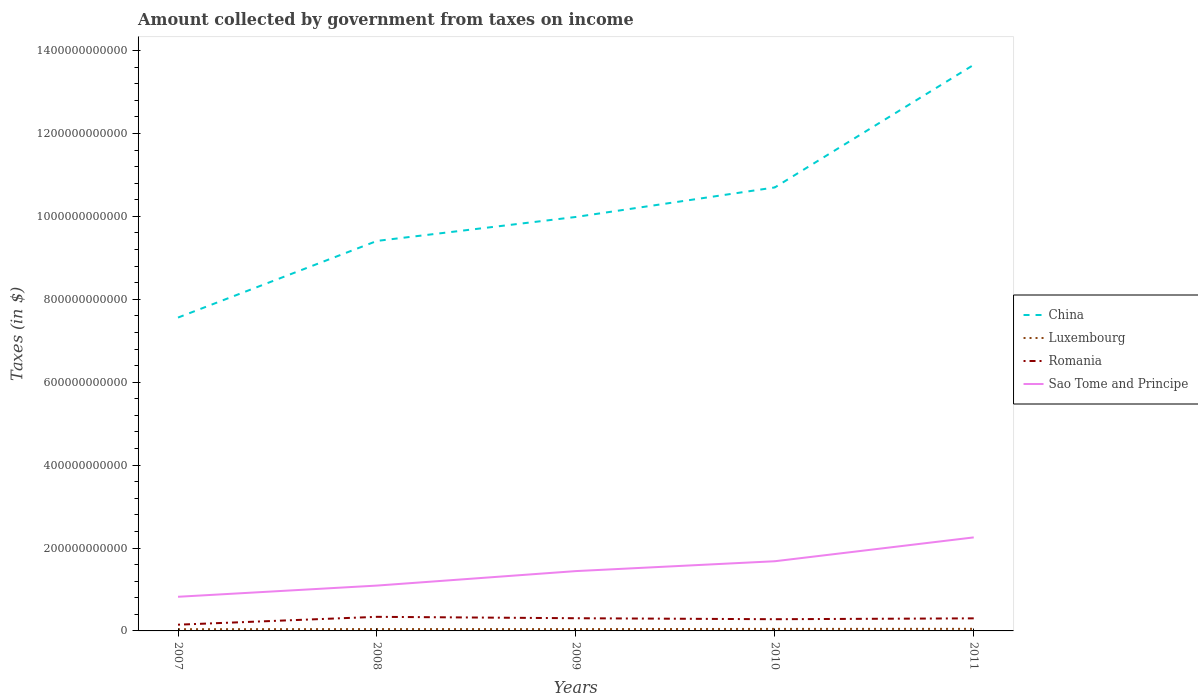How many different coloured lines are there?
Ensure brevity in your answer.  4. Across all years, what is the maximum amount collected by government from taxes on income in Romania?
Keep it short and to the point. 1.50e+1. In which year was the amount collected by government from taxes on income in China maximum?
Ensure brevity in your answer.  2007. What is the total amount collected by government from taxes on income in China in the graph?
Offer a very short reply. -2.43e+11. What is the difference between the highest and the second highest amount collected by government from taxes on income in Romania?
Provide a succinct answer. 1.90e+1. Is the amount collected by government from taxes on income in Luxembourg strictly greater than the amount collected by government from taxes on income in China over the years?
Provide a succinct answer. Yes. How many years are there in the graph?
Offer a terse response. 5. What is the difference between two consecutive major ticks on the Y-axis?
Your answer should be compact. 2.00e+11. Are the values on the major ticks of Y-axis written in scientific E-notation?
Offer a very short reply. No. Where does the legend appear in the graph?
Ensure brevity in your answer.  Center right. What is the title of the graph?
Provide a succinct answer. Amount collected by government from taxes on income. What is the label or title of the Y-axis?
Ensure brevity in your answer.  Taxes (in $). What is the Taxes (in $) of China in 2007?
Offer a terse response. 7.56e+11. What is the Taxes (in $) in Luxembourg in 2007?
Ensure brevity in your answer.  4.12e+09. What is the Taxes (in $) of Romania in 2007?
Ensure brevity in your answer.  1.50e+1. What is the Taxes (in $) in Sao Tome and Principe in 2007?
Give a very brief answer. 8.24e+1. What is the Taxes (in $) of China in 2008?
Keep it short and to the point. 9.41e+11. What is the Taxes (in $) of Luxembourg in 2008?
Your answer should be very brief. 4.46e+09. What is the Taxes (in $) of Romania in 2008?
Your answer should be very brief. 3.40e+1. What is the Taxes (in $) in Sao Tome and Principe in 2008?
Keep it short and to the point. 1.09e+11. What is the Taxes (in $) in China in 2009?
Your response must be concise. 9.99e+11. What is the Taxes (in $) of Luxembourg in 2009?
Offer a terse response. 4.41e+09. What is the Taxes (in $) in Romania in 2009?
Keep it short and to the point. 3.06e+1. What is the Taxes (in $) in Sao Tome and Principe in 2009?
Provide a succinct answer. 1.44e+11. What is the Taxes (in $) in China in 2010?
Your answer should be very brief. 1.07e+12. What is the Taxes (in $) of Luxembourg in 2010?
Your answer should be compact. 4.86e+09. What is the Taxes (in $) of Romania in 2010?
Your response must be concise. 2.82e+1. What is the Taxes (in $) in Sao Tome and Principe in 2010?
Your answer should be compact. 1.68e+11. What is the Taxes (in $) in China in 2011?
Make the answer very short. 1.37e+12. What is the Taxes (in $) of Luxembourg in 2011?
Offer a terse response. 5.00e+09. What is the Taxes (in $) in Romania in 2011?
Offer a very short reply. 3.03e+1. What is the Taxes (in $) in Sao Tome and Principe in 2011?
Give a very brief answer. 2.26e+11. Across all years, what is the maximum Taxes (in $) of China?
Your response must be concise. 1.37e+12. Across all years, what is the maximum Taxes (in $) of Luxembourg?
Offer a terse response. 5.00e+09. Across all years, what is the maximum Taxes (in $) of Romania?
Keep it short and to the point. 3.40e+1. Across all years, what is the maximum Taxes (in $) in Sao Tome and Principe?
Your answer should be compact. 2.26e+11. Across all years, what is the minimum Taxes (in $) in China?
Provide a succinct answer. 7.56e+11. Across all years, what is the minimum Taxes (in $) in Luxembourg?
Your answer should be very brief. 4.12e+09. Across all years, what is the minimum Taxes (in $) in Romania?
Your answer should be compact. 1.50e+1. Across all years, what is the minimum Taxes (in $) in Sao Tome and Principe?
Offer a very short reply. 8.24e+1. What is the total Taxes (in $) of China in the graph?
Keep it short and to the point. 5.13e+12. What is the total Taxes (in $) of Luxembourg in the graph?
Offer a terse response. 2.29e+1. What is the total Taxes (in $) of Romania in the graph?
Your answer should be compact. 1.38e+11. What is the total Taxes (in $) in Sao Tome and Principe in the graph?
Your answer should be very brief. 7.30e+11. What is the difference between the Taxes (in $) of China in 2007 and that in 2008?
Keep it short and to the point. -1.85e+11. What is the difference between the Taxes (in $) in Luxembourg in 2007 and that in 2008?
Give a very brief answer. -3.46e+08. What is the difference between the Taxes (in $) of Romania in 2007 and that in 2008?
Provide a succinct answer. -1.90e+1. What is the difference between the Taxes (in $) of Sao Tome and Principe in 2007 and that in 2008?
Offer a very short reply. -2.70e+1. What is the difference between the Taxes (in $) of China in 2007 and that in 2009?
Make the answer very short. -2.43e+11. What is the difference between the Taxes (in $) in Luxembourg in 2007 and that in 2009?
Keep it short and to the point. -2.90e+08. What is the difference between the Taxes (in $) in Romania in 2007 and that in 2009?
Ensure brevity in your answer.  -1.56e+1. What is the difference between the Taxes (in $) of Sao Tome and Principe in 2007 and that in 2009?
Provide a succinct answer. -6.19e+1. What is the difference between the Taxes (in $) in China in 2007 and that in 2010?
Your answer should be compact. -3.14e+11. What is the difference between the Taxes (in $) in Luxembourg in 2007 and that in 2010?
Your response must be concise. -7.47e+08. What is the difference between the Taxes (in $) in Romania in 2007 and that in 2010?
Give a very brief answer. -1.32e+1. What is the difference between the Taxes (in $) of Sao Tome and Principe in 2007 and that in 2010?
Ensure brevity in your answer.  -8.57e+1. What is the difference between the Taxes (in $) in China in 2007 and that in 2011?
Give a very brief answer. -6.10e+11. What is the difference between the Taxes (in $) of Luxembourg in 2007 and that in 2011?
Your response must be concise. -8.86e+08. What is the difference between the Taxes (in $) in Romania in 2007 and that in 2011?
Offer a terse response. -1.53e+1. What is the difference between the Taxes (in $) in Sao Tome and Principe in 2007 and that in 2011?
Your answer should be compact. -1.43e+11. What is the difference between the Taxes (in $) in China in 2008 and that in 2009?
Ensure brevity in your answer.  -5.78e+1. What is the difference between the Taxes (in $) in Luxembourg in 2008 and that in 2009?
Keep it short and to the point. 5.69e+07. What is the difference between the Taxes (in $) in Romania in 2008 and that in 2009?
Keep it short and to the point. 3.39e+09. What is the difference between the Taxes (in $) of Sao Tome and Principe in 2008 and that in 2009?
Your answer should be compact. -3.49e+1. What is the difference between the Taxes (in $) in China in 2008 and that in 2010?
Offer a very short reply. -1.29e+11. What is the difference between the Taxes (in $) in Luxembourg in 2008 and that in 2010?
Ensure brevity in your answer.  -4.00e+08. What is the difference between the Taxes (in $) in Romania in 2008 and that in 2010?
Offer a terse response. 5.76e+09. What is the difference between the Taxes (in $) in Sao Tome and Principe in 2008 and that in 2010?
Give a very brief answer. -5.87e+1. What is the difference between the Taxes (in $) of China in 2008 and that in 2011?
Provide a short and direct response. -4.25e+11. What is the difference between the Taxes (in $) in Luxembourg in 2008 and that in 2011?
Ensure brevity in your answer.  -5.40e+08. What is the difference between the Taxes (in $) of Romania in 2008 and that in 2011?
Offer a very short reply. 3.68e+09. What is the difference between the Taxes (in $) of Sao Tome and Principe in 2008 and that in 2011?
Offer a terse response. -1.16e+11. What is the difference between the Taxes (in $) in China in 2009 and that in 2010?
Provide a succinct answer. -7.12e+1. What is the difference between the Taxes (in $) of Luxembourg in 2009 and that in 2010?
Your answer should be compact. -4.57e+08. What is the difference between the Taxes (in $) in Romania in 2009 and that in 2010?
Offer a terse response. 2.37e+09. What is the difference between the Taxes (in $) of Sao Tome and Principe in 2009 and that in 2010?
Your answer should be compact. -2.38e+1. What is the difference between the Taxes (in $) in China in 2009 and that in 2011?
Give a very brief answer. -3.67e+11. What is the difference between the Taxes (in $) of Luxembourg in 2009 and that in 2011?
Provide a succinct answer. -5.97e+08. What is the difference between the Taxes (in $) of Romania in 2009 and that in 2011?
Your answer should be compact. 2.83e+08. What is the difference between the Taxes (in $) of Sao Tome and Principe in 2009 and that in 2011?
Keep it short and to the point. -8.13e+1. What is the difference between the Taxes (in $) in China in 2010 and that in 2011?
Keep it short and to the point. -2.96e+11. What is the difference between the Taxes (in $) of Luxembourg in 2010 and that in 2011?
Ensure brevity in your answer.  -1.40e+08. What is the difference between the Taxes (in $) of Romania in 2010 and that in 2011?
Ensure brevity in your answer.  -2.09e+09. What is the difference between the Taxes (in $) in Sao Tome and Principe in 2010 and that in 2011?
Your response must be concise. -5.75e+1. What is the difference between the Taxes (in $) of China in 2007 and the Taxes (in $) of Luxembourg in 2008?
Give a very brief answer. 7.51e+11. What is the difference between the Taxes (in $) in China in 2007 and the Taxes (in $) in Romania in 2008?
Keep it short and to the point. 7.22e+11. What is the difference between the Taxes (in $) of China in 2007 and the Taxes (in $) of Sao Tome and Principe in 2008?
Give a very brief answer. 6.46e+11. What is the difference between the Taxes (in $) in Luxembourg in 2007 and the Taxes (in $) in Romania in 2008?
Your answer should be very brief. -2.99e+1. What is the difference between the Taxes (in $) of Luxembourg in 2007 and the Taxes (in $) of Sao Tome and Principe in 2008?
Offer a very short reply. -1.05e+11. What is the difference between the Taxes (in $) of Romania in 2007 and the Taxes (in $) of Sao Tome and Principe in 2008?
Ensure brevity in your answer.  -9.44e+1. What is the difference between the Taxes (in $) of China in 2007 and the Taxes (in $) of Luxembourg in 2009?
Ensure brevity in your answer.  7.51e+11. What is the difference between the Taxes (in $) in China in 2007 and the Taxes (in $) in Romania in 2009?
Your answer should be compact. 7.25e+11. What is the difference between the Taxes (in $) in China in 2007 and the Taxes (in $) in Sao Tome and Principe in 2009?
Offer a terse response. 6.12e+11. What is the difference between the Taxes (in $) of Luxembourg in 2007 and the Taxes (in $) of Romania in 2009?
Provide a short and direct response. -2.65e+1. What is the difference between the Taxes (in $) in Luxembourg in 2007 and the Taxes (in $) in Sao Tome and Principe in 2009?
Your response must be concise. -1.40e+11. What is the difference between the Taxes (in $) of Romania in 2007 and the Taxes (in $) of Sao Tome and Principe in 2009?
Offer a terse response. -1.29e+11. What is the difference between the Taxes (in $) in China in 2007 and the Taxes (in $) in Luxembourg in 2010?
Give a very brief answer. 7.51e+11. What is the difference between the Taxes (in $) of China in 2007 and the Taxes (in $) of Romania in 2010?
Give a very brief answer. 7.28e+11. What is the difference between the Taxes (in $) in China in 2007 and the Taxes (in $) in Sao Tome and Principe in 2010?
Provide a succinct answer. 5.88e+11. What is the difference between the Taxes (in $) in Luxembourg in 2007 and the Taxes (in $) in Romania in 2010?
Your answer should be very brief. -2.41e+1. What is the difference between the Taxes (in $) in Luxembourg in 2007 and the Taxes (in $) in Sao Tome and Principe in 2010?
Your response must be concise. -1.64e+11. What is the difference between the Taxes (in $) of Romania in 2007 and the Taxes (in $) of Sao Tome and Principe in 2010?
Ensure brevity in your answer.  -1.53e+11. What is the difference between the Taxes (in $) of China in 2007 and the Taxes (in $) of Luxembourg in 2011?
Your response must be concise. 7.51e+11. What is the difference between the Taxes (in $) in China in 2007 and the Taxes (in $) in Romania in 2011?
Keep it short and to the point. 7.26e+11. What is the difference between the Taxes (in $) of China in 2007 and the Taxes (in $) of Sao Tome and Principe in 2011?
Keep it short and to the point. 5.30e+11. What is the difference between the Taxes (in $) of Luxembourg in 2007 and the Taxes (in $) of Romania in 2011?
Offer a terse response. -2.62e+1. What is the difference between the Taxes (in $) of Luxembourg in 2007 and the Taxes (in $) of Sao Tome and Principe in 2011?
Provide a short and direct response. -2.21e+11. What is the difference between the Taxes (in $) of Romania in 2007 and the Taxes (in $) of Sao Tome and Principe in 2011?
Keep it short and to the point. -2.11e+11. What is the difference between the Taxes (in $) in China in 2008 and the Taxes (in $) in Luxembourg in 2009?
Keep it short and to the point. 9.36e+11. What is the difference between the Taxes (in $) in China in 2008 and the Taxes (in $) in Romania in 2009?
Make the answer very short. 9.10e+11. What is the difference between the Taxes (in $) in China in 2008 and the Taxes (in $) in Sao Tome and Principe in 2009?
Offer a very short reply. 7.96e+11. What is the difference between the Taxes (in $) of Luxembourg in 2008 and the Taxes (in $) of Romania in 2009?
Offer a terse response. -2.61e+1. What is the difference between the Taxes (in $) of Luxembourg in 2008 and the Taxes (in $) of Sao Tome and Principe in 2009?
Your response must be concise. -1.40e+11. What is the difference between the Taxes (in $) in Romania in 2008 and the Taxes (in $) in Sao Tome and Principe in 2009?
Offer a very short reply. -1.10e+11. What is the difference between the Taxes (in $) in China in 2008 and the Taxes (in $) in Luxembourg in 2010?
Provide a succinct answer. 9.36e+11. What is the difference between the Taxes (in $) of China in 2008 and the Taxes (in $) of Romania in 2010?
Provide a succinct answer. 9.13e+11. What is the difference between the Taxes (in $) in China in 2008 and the Taxes (in $) in Sao Tome and Principe in 2010?
Offer a terse response. 7.73e+11. What is the difference between the Taxes (in $) of Luxembourg in 2008 and the Taxes (in $) of Romania in 2010?
Your answer should be very brief. -2.38e+1. What is the difference between the Taxes (in $) in Luxembourg in 2008 and the Taxes (in $) in Sao Tome and Principe in 2010?
Make the answer very short. -1.64e+11. What is the difference between the Taxes (in $) of Romania in 2008 and the Taxes (in $) of Sao Tome and Principe in 2010?
Your response must be concise. -1.34e+11. What is the difference between the Taxes (in $) in China in 2008 and the Taxes (in $) in Luxembourg in 2011?
Make the answer very short. 9.36e+11. What is the difference between the Taxes (in $) in China in 2008 and the Taxes (in $) in Romania in 2011?
Provide a short and direct response. 9.10e+11. What is the difference between the Taxes (in $) in China in 2008 and the Taxes (in $) in Sao Tome and Principe in 2011?
Keep it short and to the point. 7.15e+11. What is the difference between the Taxes (in $) in Luxembourg in 2008 and the Taxes (in $) in Romania in 2011?
Give a very brief answer. -2.59e+1. What is the difference between the Taxes (in $) in Luxembourg in 2008 and the Taxes (in $) in Sao Tome and Principe in 2011?
Make the answer very short. -2.21e+11. What is the difference between the Taxes (in $) in Romania in 2008 and the Taxes (in $) in Sao Tome and Principe in 2011?
Your answer should be compact. -1.92e+11. What is the difference between the Taxes (in $) of China in 2009 and the Taxes (in $) of Luxembourg in 2010?
Ensure brevity in your answer.  9.94e+11. What is the difference between the Taxes (in $) of China in 2009 and the Taxes (in $) of Romania in 2010?
Your answer should be very brief. 9.70e+11. What is the difference between the Taxes (in $) of China in 2009 and the Taxes (in $) of Sao Tome and Principe in 2010?
Give a very brief answer. 8.30e+11. What is the difference between the Taxes (in $) in Luxembourg in 2009 and the Taxes (in $) in Romania in 2010?
Keep it short and to the point. -2.38e+1. What is the difference between the Taxes (in $) of Luxembourg in 2009 and the Taxes (in $) of Sao Tome and Principe in 2010?
Your response must be concise. -1.64e+11. What is the difference between the Taxes (in $) in Romania in 2009 and the Taxes (in $) in Sao Tome and Principe in 2010?
Keep it short and to the point. -1.37e+11. What is the difference between the Taxes (in $) in China in 2009 and the Taxes (in $) in Luxembourg in 2011?
Provide a succinct answer. 9.94e+11. What is the difference between the Taxes (in $) in China in 2009 and the Taxes (in $) in Romania in 2011?
Your answer should be very brief. 9.68e+11. What is the difference between the Taxes (in $) of China in 2009 and the Taxes (in $) of Sao Tome and Principe in 2011?
Ensure brevity in your answer.  7.73e+11. What is the difference between the Taxes (in $) of Luxembourg in 2009 and the Taxes (in $) of Romania in 2011?
Give a very brief answer. -2.59e+1. What is the difference between the Taxes (in $) of Luxembourg in 2009 and the Taxes (in $) of Sao Tome and Principe in 2011?
Provide a short and direct response. -2.21e+11. What is the difference between the Taxes (in $) in Romania in 2009 and the Taxes (in $) in Sao Tome and Principe in 2011?
Provide a short and direct response. -1.95e+11. What is the difference between the Taxes (in $) of China in 2010 and the Taxes (in $) of Luxembourg in 2011?
Your answer should be compact. 1.06e+12. What is the difference between the Taxes (in $) in China in 2010 and the Taxes (in $) in Romania in 2011?
Provide a succinct answer. 1.04e+12. What is the difference between the Taxes (in $) in China in 2010 and the Taxes (in $) in Sao Tome and Principe in 2011?
Make the answer very short. 8.44e+11. What is the difference between the Taxes (in $) of Luxembourg in 2010 and the Taxes (in $) of Romania in 2011?
Give a very brief answer. -2.55e+1. What is the difference between the Taxes (in $) of Luxembourg in 2010 and the Taxes (in $) of Sao Tome and Principe in 2011?
Give a very brief answer. -2.21e+11. What is the difference between the Taxes (in $) of Romania in 2010 and the Taxes (in $) of Sao Tome and Principe in 2011?
Offer a very short reply. -1.97e+11. What is the average Taxes (in $) of China per year?
Offer a very short reply. 1.03e+12. What is the average Taxes (in $) in Luxembourg per year?
Your answer should be compact. 4.57e+09. What is the average Taxes (in $) in Romania per year?
Offer a very short reply. 2.76e+1. What is the average Taxes (in $) of Sao Tome and Principe per year?
Offer a terse response. 1.46e+11. In the year 2007, what is the difference between the Taxes (in $) of China and Taxes (in $) of Luxembourg?
Make the answer very short. 7.52e+11. In the year 2007, what is the difference between the Taxes (in $) of China and Taxes (in $) of Romania?
Your answer should be very brief. 7.41e+11. In the year 2007, what is the difference between the Taxes (in $) in China and Taxes (in $) in Sao Tome and Principe?
Offer a terse response. 6.74e+11. In the year 2007, what is the difference between the Taxes (in $) in Luxembourg and Taxes (in $) in Romania?
Keep it short and to the point. -1.09e+1. In the year 2007, what is the difference between the Taxes (in $) of Luxembourg and Taxes (in $) of Sao Tome and Principe?
Offer a very short reply. -7.83e+1. In the year 2007, what is the difference between the Taxes (in $) of Romania and Taxes (in $) of Sao Tome and Principe?
Your answer should be compact. -6.74e+1. In the year 2008, what is the difference between the Taxes (in $) of China and Taxes (in $) of Luxembourg?
Offer a very short reply. 9.36e+11. In the year 2008, what is the difference between the Taxes (in $) of China and Taxes (in $) of Romania?
Make the answer very short. 9.07e+11. In the year 2008, what is the difference between the Taxes (in $) in China and Taxes (in $) in Sao Tome and Principe?
Make the answer very short. 8.31e+11. In the year 2008, what is the difference between the Taxes (in $) of Luxembourg and Taxes (in $) of Romania?
Provide a succinct answer. -2.95e+1. In the year 2008, what is the difference between the Taxes (in $) in Luxembourg and Taxes (in $) in Sao Tome and Principe?
Offer a very short reply. -1.05e+11. In the year 2008, what is the difference between the Taxes (in $) of Romania and Taxes (in $) of Sao Tome and Principe?
Your answer should be very brief. -7.54e+1. In the year 2009, what is the difference between the Taxes (in $) in China and Taxes (in $) in Luxembourg?
Provide a short and direct response. 9.94e+11. In the year 2009, what is the difference between the Taxes (in $) of China and Taxes (in $) of Romania?
Provide a succinct answer. 9.68e+11. In the year 2009, what is the difference between the Taxes (in $) of China and Taxes (in $) of Sao Tome and Principe?
Your response must be concise. 8.54e+11. In the year 2009, what is the difference between the Taxes (in $) of Luxembourg and Taxes (in $) of Romania?
Make the answer very short. -2.62e+1. In the year 2009, what is the difference between the Taxes (in $) in Luxembourg and Taxes (in $) in Sao Tome and Principe?
Give a very brief answer. -1.40e+11. In the year 2009, what is the difference between the Taxes (in $) in Romania and Taxes (in $) in Sao Tome and Principe?
Make the answer very short. -1.14e+11. In the year 2010, what is the difference between the Taxes (in $) in China and Taxes (in $) in Luxembourg?
Offer a terse response. 1.06e+12. In the year 2010, what is the difference between the Taxes (in $) in China and Taxes (in $) in Romania?
Offer a terse response. 1.04e+12. In the year 2010, what is the difference between the Taxes (in $) in China and Taxes (in $) in Sao Tome and Principe?
Keep it short and to the point. 9.02e+11. In the year 2010, what is the difference between the Taxes (in $) in Luxembourg and Taxes (in $) in Romania?
Ensure brevity in your answer.  -2.34e+1. In the year 2010, what is the difference between the Taxes (in $) of Luxembourg and Taxes (in $) of Sao Tome and Principe?
Your response must be concise. -1.63e+11. In the year 2010, what is the difference between the Taxes (in $) of Romania and Taxes (in $) of Sao Tome and Principe?
Your answer should be very brief. -1.40e+11. In the year 2011, what is the difference between the Taxes (in $) of China and Taxes (in $) of Luxembourg?
Your response must be concise. 1.36e+12. In the year 2011, what is the difference between the Taxes (in $) in China and Taxes (in $) in Romania?
Your answer should be very brief. 1.34e+12. In the year 2011, what is the difference between the Taxes (in $) in China and Taxes (in $) in Sao Tome and Principe?
Ensure brevity in your answer.  1.14e+12. In the year 2011, what is the difference between the Taxes (in $) in Luxembourg and Taxes (in $) in Romania?
Offer a very short reply. -2.53e+1. In the year 2011, what is the difference between the Taxes (in $) of Luxembourg and Taxes (in $) of Sao Tome and Principe?
Your answer should be compact. -2.21e+11. In the year 2011, what is the difference between the Taxes (in $) of Romania and Taxes (in $) of Sao Tome and Principe?
Provide a succinct answer. -1.95e+11. What is the ratio of the Taxes (in $) of China in 2007 to that in 2008?
Ensure brevity in your answer.  0.8. What is the ratio of the Taxes (in $) of Luxembourg in 2007 to that in 2008?
Your response must be concise. 0.92. What is the ratio of the Taxes (in $) of Romania in 2007 to that in 2008?
Your answer should be very brief. 0.44. What is the ratio of the Taxes (in $) of Sao Tome and Principe in 2007 to that in 2008?
Make the answer very short. 0.75. What is the ratio of the Taxes (in $) of China in 2007 to that in 2009?
Keep it short and to the point. 0.76. What is the ratio of the Taxes (in $) of Luxembourg in 2007 to that in 2009?
Provide a succinct answer. 0.93. What is the ratio of the Taxes (in $) of Romania in 2007 to that in 2009?
Make the answer very short. 0.49. What is the ratio of the Taxes (in $) of Sao Tome and Principe in 2007 to that in 2009?
Make the answer very short. 0.57. What is the ratio of the Taxes (in $) in China in 2007 to that in 2010?
Provide a succinct answer. 0.71. What is the ratio of the Taxes (in $) of Luxembourg in 2007 to that in 2010?
Your answer should be very brief. 0.85. What is the ratio of the Taxes (in $) in Romania in 2007 to that in 2010?
Ensure brevity in your answer.  0.53. What is the ratio of the Taxes (in $) in Sao Tome and Principe in 2007 to that in 2010?
Offer a terse response. 0.49. What is the ratio of the Taxes (in $) of China in 2007 to that in 2011?
Offer a very short reply. 0.55. What is the ratio of the Taxes (in $) in Luxembourg in 2007 to that in 2011?
Provide a succinct answer. 0.82. What is the ratio of the Taxes (in $) in Romania in 2007 to that in 2011?
Keep it short and to the point. 0.5. What is the ratio of the Taxes (in $) of Sao Tome and Principe in 2007 to that in 2011?
Provide a short and direct response. 0.37. What is the ratio of the Taxes (in $) in China in 2008 to that in 2009?
Offer a terse response. 0.94. What is the ratio of the Taxes (in $) of Luxembourg in 2008 to that in 2009?
Provide a short and direct response. 1.01. What is the ratio of the Taxes (in $) in Romania in 2008 to that in 2009?
Your answer should be compact. 1.11. What is the ratio of the Taxes (in $) in Sao Tome and Principe in 2008 to that in 2009?
Your answer should be very brief. 0.76. What is the ratio of the Taxes (in $) of China in 2008 to that in 2010?
Your answer should be very brief. 0.88. What is the ratio of the Taxes (in $) in Luxembourg in 2008 to that in 2010?
Offer a very short reply. 0.92. What is the ratio of the Taxes (in $) in Romania in 2008 to that in 2010?
Your answer should be compact. 1.2. What is the ratio of the Taxes (in $) in Sao Tome and Principe in 2008 to that in 2010?
Provide a short and direct response. 0.65. What is the ratio of the Taxes (in $) in China in 2008 to that in 2011?
Your response must be concise. 0.69. What is the ratio of the Taxes (in $) of Luxembourg in 2008 to that in 2011?
Offer a very short reply. 0.89. What is the ratio of the Taxes (in $) in Romania in 2008 to that in 2011?
Your answer should be very brief. 1.12. What is the ratio of the Taxes (in $) in Sao Tome and Principe in 2008 to that in 2011?
Your response must be concise. 0.48. What is the ratio of the Taxes (in $) in China in 2009 to that in 2010?
Offer a very short reply. 0.93. What is the ratio of the Taxes (in $) of Luxembourg in 2009 to that in 2010?
Keep it short and to the point. 0.91. What is the ratio of the Taxes (in $) in Romania in 2009 to that in 2010?
Make the answer very short. 1.08. What is the ratio of the Taxes (in $) of Sao Tome and Principe in 2009 to that in 2010?
Provide a short and direct response. 0.86. What is the ratio of the Taxes (in $) of China in 2009 to that in 2011?
Provide a succinct answer. 0.73. What is the ratio of the Taxes (in $) in Luxembourg in 2009 to that in 2011?
Ensure brevity in your answer.  0.88. What is the ratio of the Taxes (in $) of Romania in 2009 to that in 2011?
Your answer should be very brief. 1.01. What is the ratio of the Taxes (in $) of Sao Tome and Principe in 2009 to that in 2011?
Offer a terse response. 0.64. What is the ratio of the Taxes (in $) in China in 2010 to that in 2011?
Keep it short and to the point. 0.78. What is the ratio of the Taxes (in $) of Luxembourg in 2010 to that in 2011?
Provide a succinct answer. 0.97. What is the ratio of the Taxes (in $) of Romania in 2010 to that in 2011?
Keep it short and to the point. 0.93. What is the ratio of the Taxes (in $) of Sao Tome and Principe in 2010 to that in 2011?
Offer a very short reply. 0.75. What is the difference between the highest and the second highest Taxes (in $) in China?
Ensure brevity in your answer.  2.96e+11. What is the difference between the highest and the second highest Taxes (in $) of Luxembourg?
Offer a very short reply. 1.40e+08. What is the difference between the highest and the second highest Taxes (in $) of Romania?
Offer a terse response. 3.39e+09. What is the difference between the highest and the second highest Taxes (in $) in Sao Tome and Principe?
Give a very brief answer. 5.75e+1. What is the difference between the highest and the lowest Taxes (in $) in China?
Keep it short and to the point. 6.10e+11. What is the difference between the highest and the lowest Taxes (in $) in Luxembourg?
Ensure brevity in your answer.  8.86e+08. What is the difference between the highest and the lowest Taxes (in $) of Romania?
Offer a very short reply. 1.90e+1. What is the difference between the highest and the lowest Taxes (in $) in Sao Tome and Principe?
Offer a terse response. 1.43e+11. 